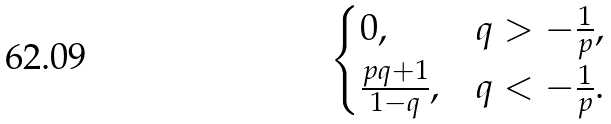Convert formula to latex. <formula><loc_0><loc_0><loc_500><loc_500>\begin{cases} 0 , & q > - \frac { 1 } { p } , \\ \frac { p q + 1 } { 1 - q } , & q < - \frac { 1 } { p } . \end{cases}</formula> 